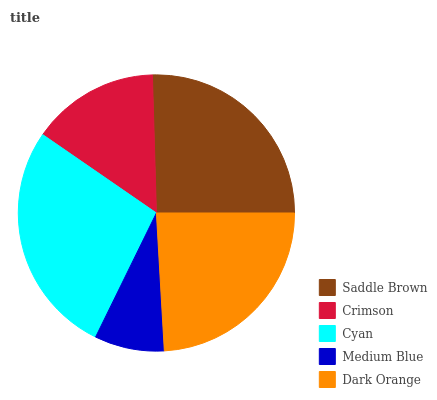Is Medium Blue the minimum?
Answer yes or no. Yes. Is Cyan the maximum?
Answer yes or no. Yes. Is Crimson the minimum?
Answer yes or no. No. Is Crimson the maximum?
Answer yes or no. No. Is Saddle Brown greater than Crimson?
Answer yes or no. Yes. Is Crimson less than Saddle Brown?
Answer yes or no. Yes. Is Crimson greater than Saddle Brown?
Answer yes or no. No. Is Saddle Brown less than Crimson?
Answer yes or no. No. Is Dark Orange the high median?
Answer yes or no. Yes. Is Dark Orange the low median?
Answer yes or no. Yes. Is Crimson the high median?
Answer yes or no. No. Is Crimson the low median?
Answer yes or no. No. 